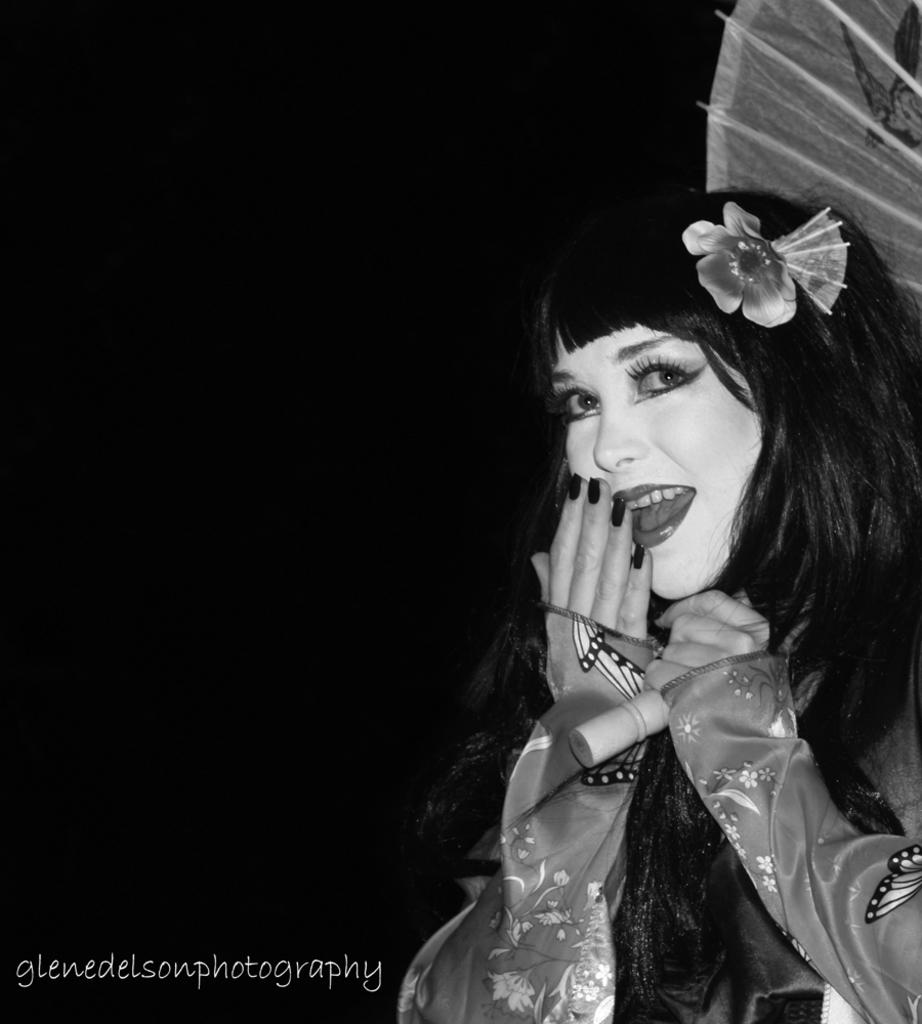Who is the main subject in the image? There is a woman in the image. What is the woman wearing? The woman is wearing a Chinese traditional costume. Where is the woman located in the image? The woman is on the right side of the image. What is the color of the background in the image? The background of the image is dark. What type of crack can be seen in the image? There is no crack present in the image. What kind of store or office can be seen in the background of the image? There is no store or office visible in the image; the background is dark. 